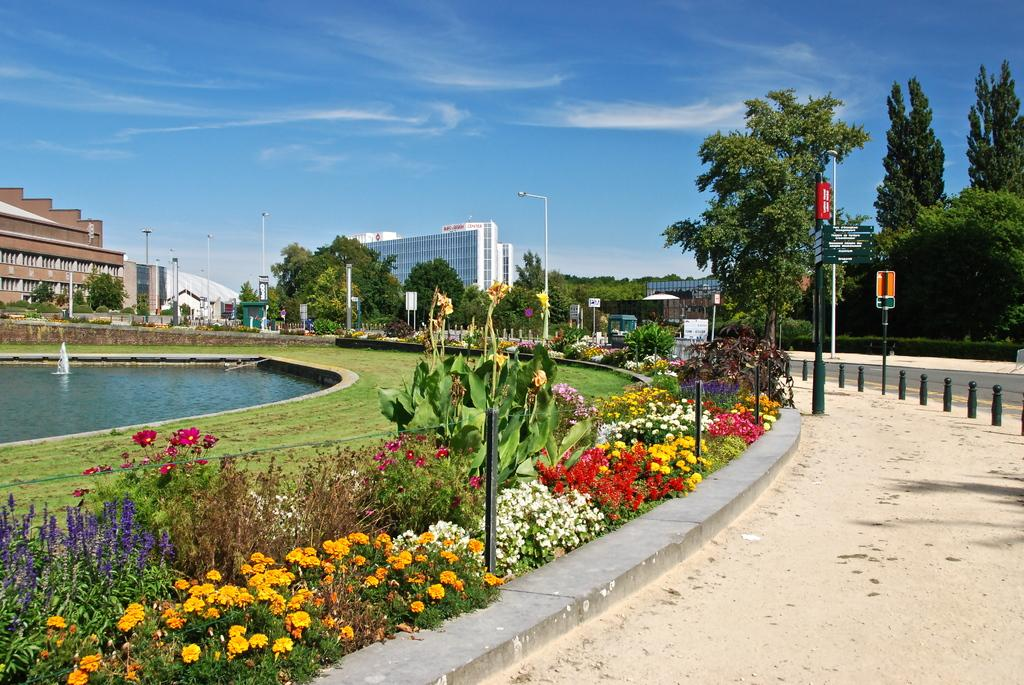What type of vegetation can be seen in the image? There are flower plants and trees visible in the image. What type of structures are present in the image? There are poles and street lights visible in the image. What type of ground cover is present in the image? There is grass visible in the image. What can be seen in the background of the image? There is water, buildings, and sky visible in the background of the image. What other objects can be seen in the background of the image? There are other objects visible in the background of the image, but their specific nature is not mentioned in the provided facts. What type of pickle is hanging from the tree in the image? There is no pickle present in the image; it features flower plants, trees, poles, street lights, grass, water, buildings, and sky. How many rings can be seen on the fingers of the people in the image? There are no people present in the image, so it is not possible to determine the number of rings on their fingers. 